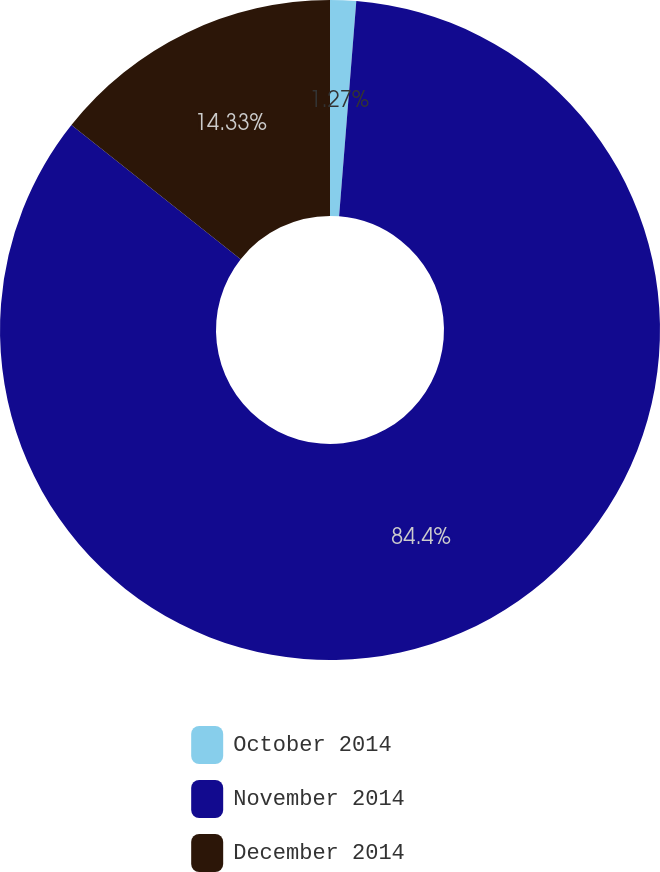<chart> <loc_0><loc_0><loc_500><loc_500><pie_chart><fcel>October 2014<fcel>November 2014<fcel>December 2014<nl><fcel>1.27%<fcel>84.39%<fcel>14.33%<nl></chart> 